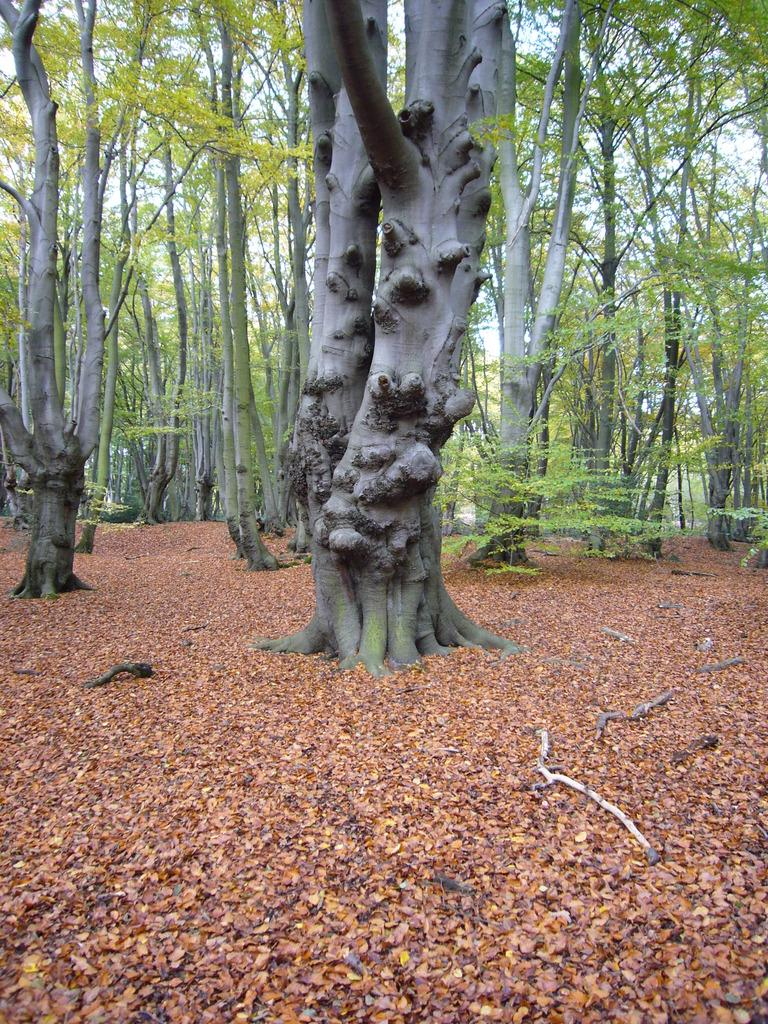What type of surface is visible in the image? There is ground visible in the image. What can be found on the ground in the image? There are leaves and sticks on the ground in the image. What is visible in the background of the image? There are trees in the background of the image. What type of drink is being served at the dinner in the image? There is no dinner or drink present in the image; it features ground with leaves and sticks, and trees in the background. 